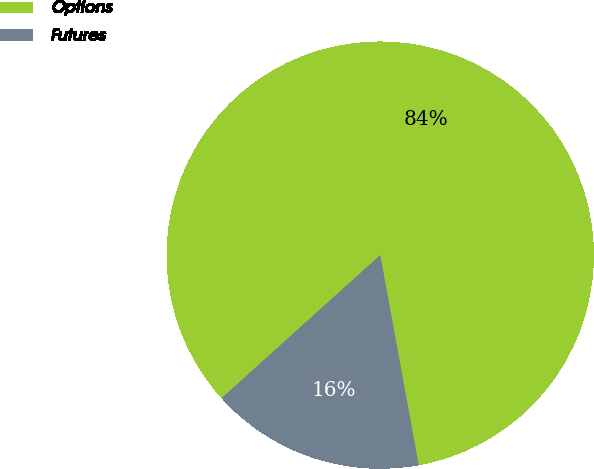Convert chart to OTSL. <chart><loc_0><loc_0><loc_500><loc_500><pie_chart><fcel>Options<fcel>Futures<nl><fcel>83.8%<fcel>16.2%<nl></chart> 